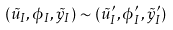<formula> <loc_0><loc_0><loc_500><loc_500>( \tilde { u } _ { I } , \phi _ { I } , \tilde { y } _ { I } ) \sim ( \tilde { u } ^ { \prime } _ { I } , \phi ^ { \prime } _ { I } , \tilde { y } ^ { \prime } _ { I } )</formula> 